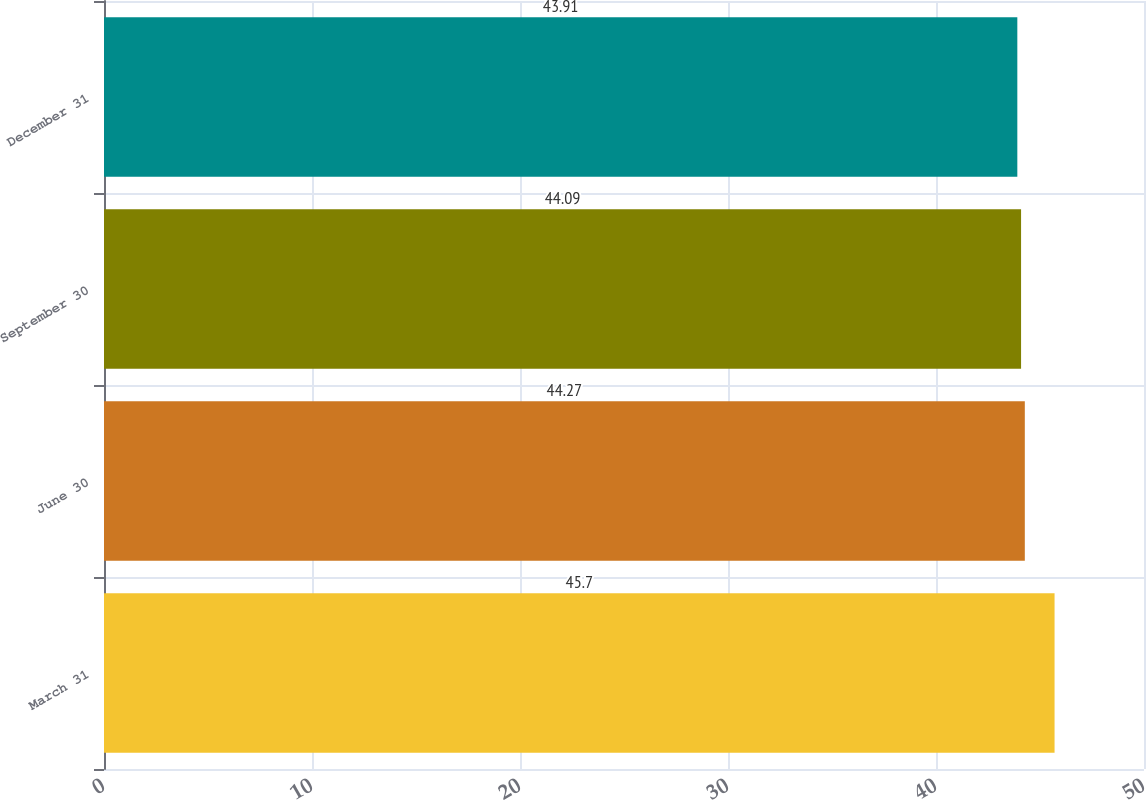Convert chart to OTSL. <chart><loc_0><loc_0><loc_500><loc_500><bar_chart><fcel>March 31<fcel>June 30<fcel>September 30<fcel>December 31<nl><fcel>45.7<fcel>44.27<fcel>44.09<fcel>43.91<nl></chart> 